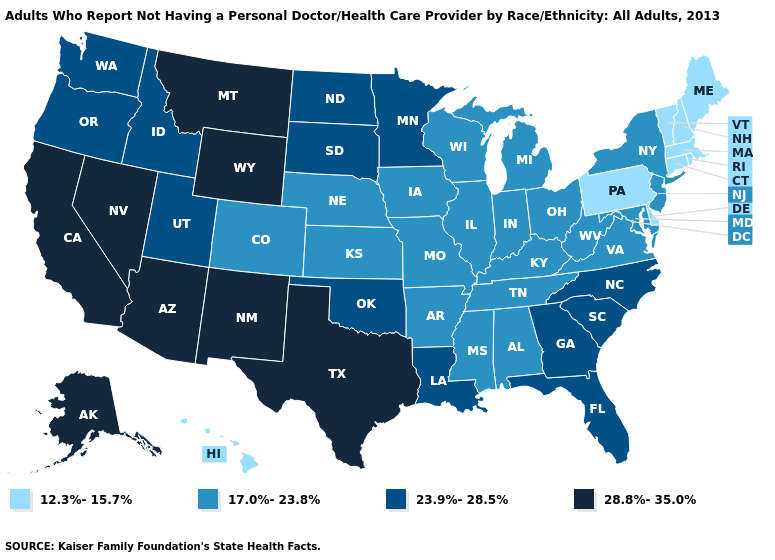Does Maryland have the highest value in the South?
Give a very brief answer. No. Among the states that border Delaware , which have the lowest value?
Quick response, please. Pennsylvania. Does Montana have the highest value in the USA?
Quick response, please. Yes. What is the value of Kentucky?
Quick response, please. 17.0%-23.8%. Name the states that have a value in the range 28.8%-35.0%?
Answer briefly. Alaska, Arizona, California, Montana, Nevada, New Mexico, Texas, Wyoming. What is the value of North Dakota?
Quick response, please. 23.9%-28.5%. Name the states that have a value in the range 28.8%-35.0%?
Write a very short answer. Alaska, Arizona, California, Montana, Nevada, New Mexico, Texas, Wyoming. What is the value of Alabama?
Quick response, please. 17.0%-23.8%. Does New Hampshire have the lowest value in the USA?
Short answer required. Yes. Does New Mexico have the highest value in the West?
Give a very brief answer. Yes. Name the states that have a value in the range 23.9%-28.5%?
Give a very brief answer. Florida, Georgia, Idaho, Louisiana, Minnesota, North Carolina, North Dakota, Oklahoma, Oregon, South Carolina, South Dakota, Utah, Washington. What is the highest value in the USA?
Answer briefly. 28.8%-35.0%. Is the legend a continuous bar?
Short answer required. No. How many symbols are there in the legend?
Give a very brief answer. 4. Which states have the lowest value in the USA?
Short answer required. Connecticut, Delaware, Hawaii, Maine, Massachusetts, New Hampshire, Pennsylvania, Rhode Island, Vermont. 